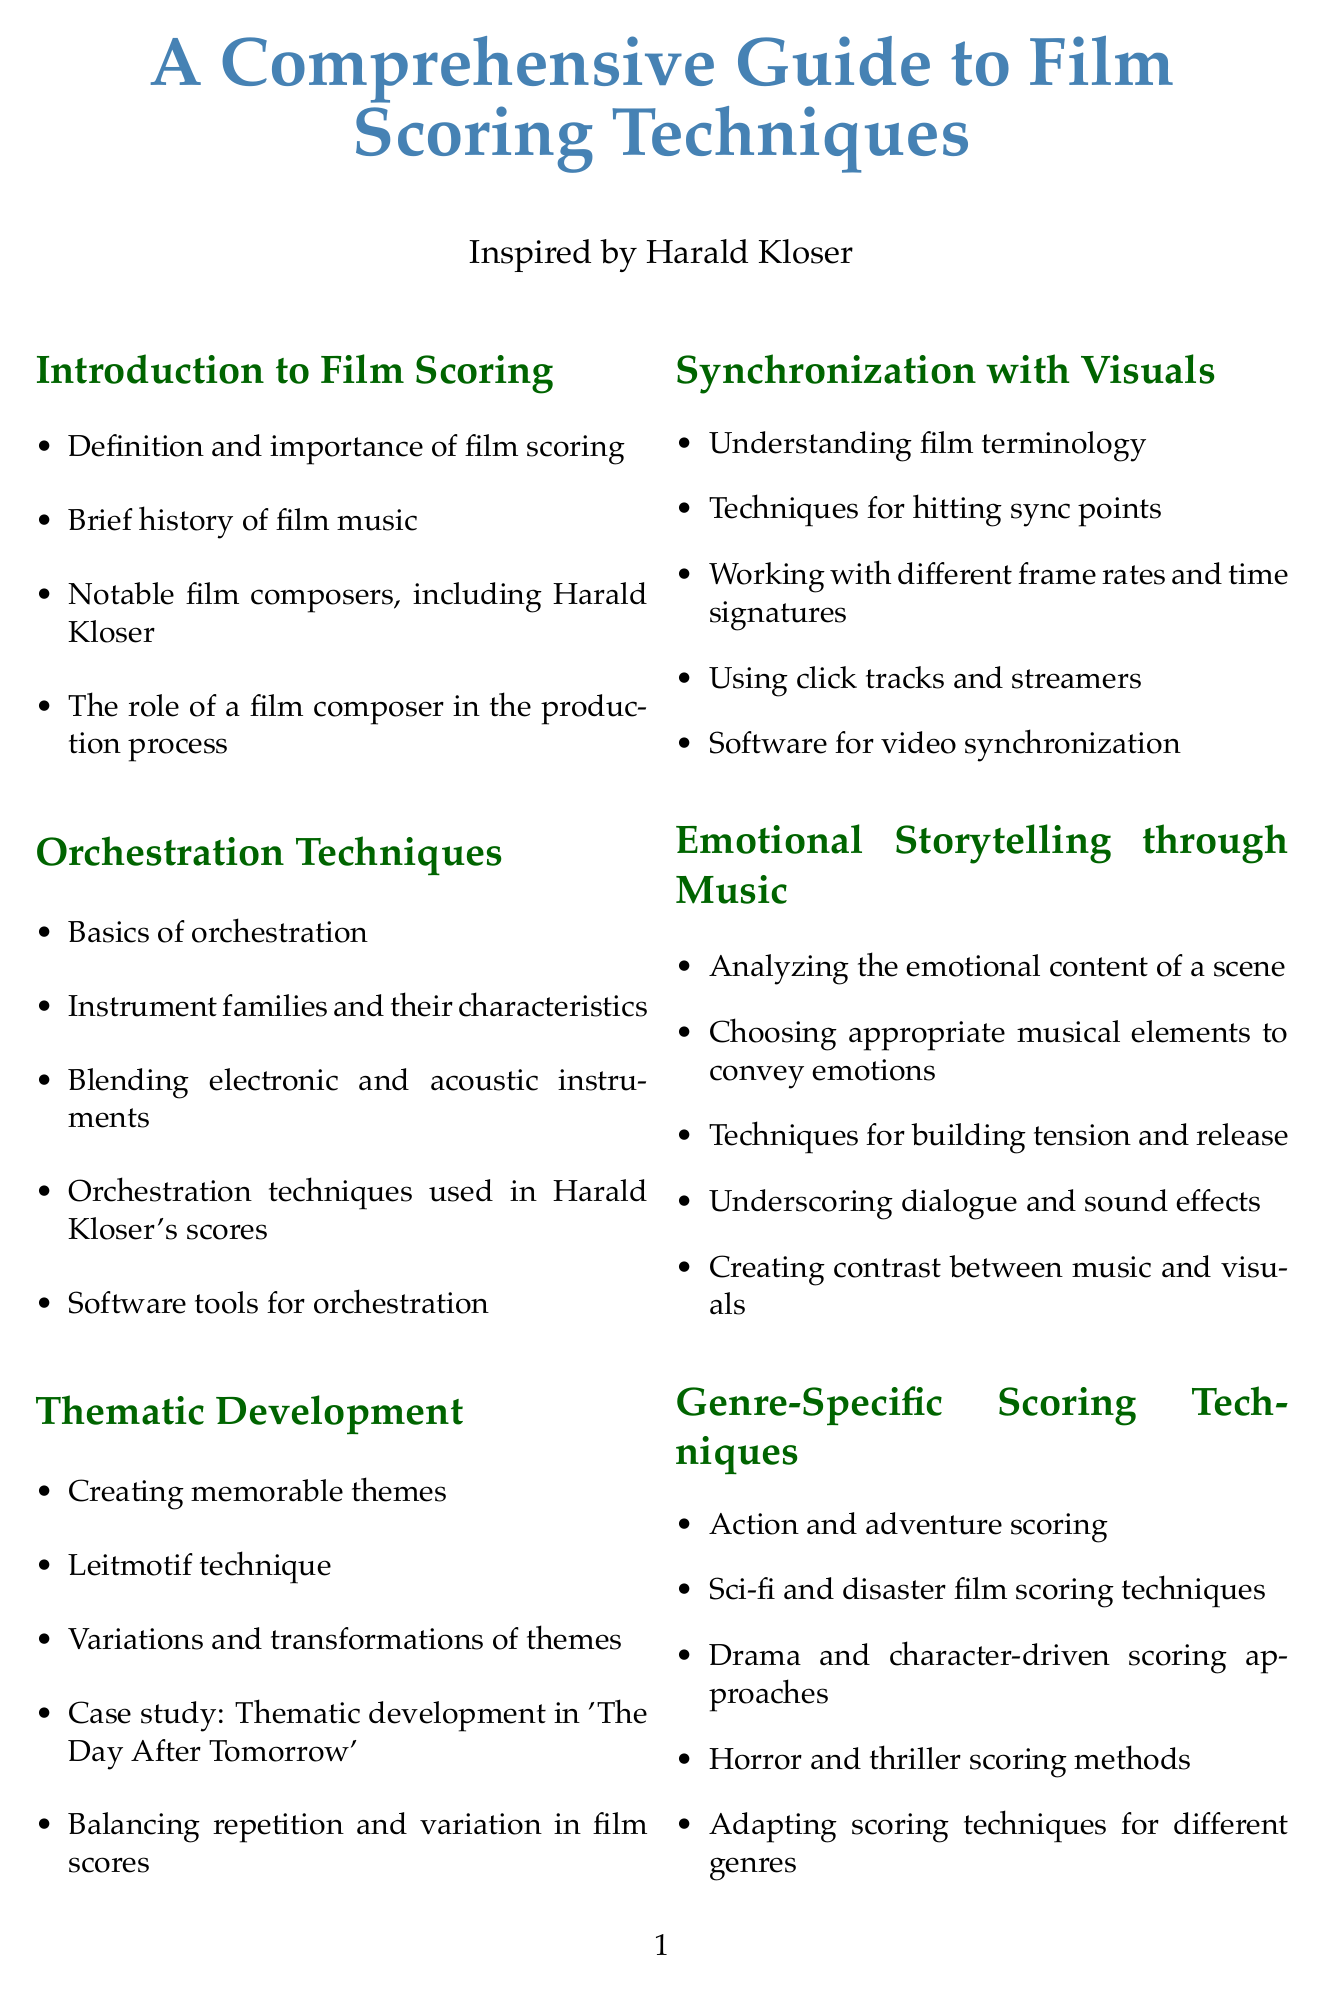What is the title of the document? The title is clearly mentioned at the beginning, which provides the main subject of the manual.
Answer: A Comprehensive Guide to Film Scoring Techniques Who is a notable film composer mentioned in the introduction? The introduction lists several film composers, including one specifically referenced in the context of the guide.
Answer: Harald Kloser What software is suggested for orchestration? The orchestration section includes key software tools that are beneficial for composers.
Answer: Vienna Symphonic Library What technique is emphasized in thematic development? The thematic development section introduces a key method for creating themes, which is a fundamental aspect of film scoring.
Answer: Leitmotif technique Which digital audio workstation is listed under technology and tools? The technology section includes various software used in the film scoring process, providing examples of DAWs.
Answer: Logic Pro X In what genre is action and adventure scoring referenced? The section about genre-specific scoring techniques includes various genres, specifically highlighting one type of scoring.
Answer: Action and adventure What is the primary focus of the "Emotional Storytelling through Music" section? The section discusses how music impacts the emotional narrative of film scenes and the techniques involved.
Answer: Analyzing the emotional content of a scene What is one recommended online course for aspiring composers? The resources section includes various educational opportunities tailored for film scoring, including online courses.
Answer: MasterClass: Hans Zimmer Teaches Film Scoring What is one exercise included in the exercises and projects section? The exercises listed provide practical opportunities to apply scoring techniques discussed in the guide.
Answer: Composing a theme and developing variations 